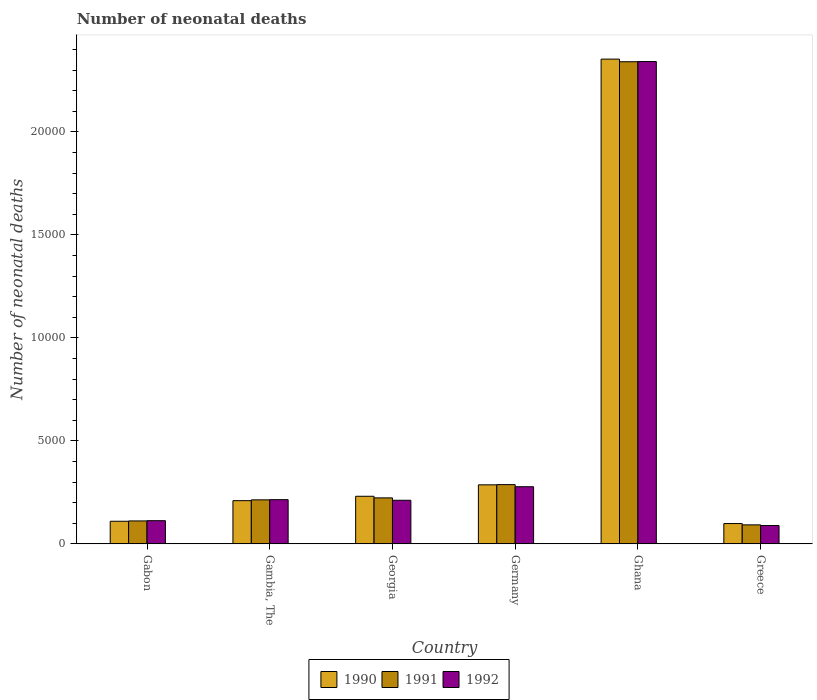How many different coloured bars are there?
Provide a short and direct response. 3. How many bars are there on the 1st tick from the left?
Give a very brief answer. 3. What is the label of the 1st group of bars from the left?
Your answer should be very brief. Gabon. What is the number of neonatal deaths in in 1990 in Georgia?
Offer a very short reply. 2310. Across all countries, what is the maximum number of neonatal deaths in in 1990?
Make the answer very short. 2.35e+04. Across all countries, what is the minimum number of neonatal deaths in in 1990?
Offer a terse response. 986. In which country was the number of neonatal deaths in in 1990 maximum?
Provide a succinct answer. Ghana. In which country was the number of neonatal deaths in in 1990 minimum?
Make the answer very short. Greece. What is the total number of neonatal deaths in in 1991 in the graph?
Offer a very short reply. 3.27e+04. What is the difference between the number of neonatal deaths in in 1991 in Gabon and that in Germany?
Provide a succinct answer. -1763. What is the difference between the number of neonatal deaths in in 1990 in Georgia and the number of neonatal deaths in in 1991 in Gambia, The?
Ensure brevity in your answer.  174. What is the average number of neonatal deaths in in 1990 per country?
Ensure brevity in your answer.  5480.67. What is the difference between the number of neonatal deaths in of/in 1990 and number of neonatal deaths in of/in 1992 in Gambia, The?
Give a very brief answer. -48. In how many countries, is the number of neonatal deaths in in 1992 greater than 17000?
Your answer should be very brief. 1. What is the ratio of the number of neonatal deaths in in 1991 in Ghana to that in Greece?
Provide a succinct answer. 25.38. What is the difference between the highest and the second highest number of neonatal deaths in in 1992?
Ensure brevity in your answer.  -2.13e+04. What is the difference between the highest and the lowest number of neonatal deaths in in 1992?
Provide a succinct answer. 2.25e+04. What does the 2nd bar from the left in Georgia represents?
Ensure brevity in your answer.  1991. What is the difference between two consecutive major ticks on the Y-axis?
Make the answer very short. 5000. Does the graph contain any zero values?
Your answer should be compact. No. Does the graph contain grids?
Offer a terse response. No. How are the legend labels stacked?
Your response must be concise. Horizontal. What is the title of the graph?
Give a very brief answer. Number of neonatal deaths. Does "1994" appear as one of the legend labels in the graph?
Provide a short and direct response. No. What is the label or title of the X-axis?
Give a very brief answer. Country. What is the label or title of the Y-axis?
Provide a short and direct response. Number of neonatal deaths. What is the Number of neonatal deaths of 1990 in Gabon?
Provide a succinct answer. 1097. What is the Number of neonatal deaths in 1991 in Gabon?
Your response must be concise. 1113. What is the Number of neonatal deaths of 1992 in Gabon?
Your answer should be compact. 1125. What is the Number of neonatal deaths in 1990 in Gambia, The?
Offer a terse response. 2097. What is the Number of neonatal deaths of 1991 in Gambia, The?
Provide a succinct answer. 2136. What is the Number of neonatal deaths of 1992 in Gambia, The?
Your answer should be very brief. 2145. What is the Number of neonatal deaths of 1990 in Georgia?
Give a very brief answer. 2310. What is the Number of neonatal deaths in 1991 in Georgia?
Your answer should be compact. 2232. What is the Number of neonatal deaths in 1992 in Georgia?
Provide a succinct answer. 2116. What is the Number of neonatal deaths in 1990 in Germany?
Provide a succinct answer. 2865. What is the Number of neonatal deaths in 1991 in Germany?
Your response must be concise. 2876. What is the Number of neonatal deaths in 1992 in Germany?
Offer a terse response. 2773. What is the Number of neonatal deaths of 1990 in Ghana?
Ensure brevity in your answer.  2.35e+04. What is the Number of neonatal deaths of 1991 in Ghana?
Your answer should be very brief. 2.34e+04. What is the Number of neonatal deaths in 1992 in Ghana?
Give a very brief answer. 2.34e+04. What is the Number of neonatal deaths in 1990 in Greece?
Offer a very short reply. 986. What is the Number of neonatal deaths in 1991 in Greece?
Offer a terse response. 922. What is the Number of neonatal deaths in 1992 in Greece?
Make the answer very short. 889. Across all countries, what is the maximum Number of neonatal deaths of 1990?
Your response must be concise. 2.35e+04. Across all countries, what is the maximum Number of neonatal deaths in 1991?
Your answer should be very brief. 2.34e+04. Across all countries, what is the maximum Number of neonatal deaths of 1992?
Your answer should be compact. 2.34e+04. Across all countries, what is the minimum Number of neonatal deaths in 1990?
Provide a short and direct response. 986. Across all countries, what is the minimum Number of neonatal deaths in 1991?
Your answer should be very brief. 922. Across all countries, what is the minimum Number of neonatal deaths in 1992?
Your answer should be very brief. 889. What is the total Number of neonatal deaths of 1990 in the graph?
Offer a terse response. 3.29e+04. What is the total Number of neonatal deaths of 1991 in the graph?
Offer a very short reply. 3.27e+04. What is the total Number of neonatal deaths of 1992 in the graph?
Give a very brief answer. 3.25e+04. What is the difference between the Number of neonatal deaths of 1990 in Gabon and that in Gambia, The?
Provide a succinct answer. -1000. What is the difference between the Number of neonatal deaths in 1991 in Gabon and that in Gambia, The?
Give a very brief answer. -1023. What is the difference between the Number of neonatal deaths of 1992 in Gabon and that in Gambia, The?
Provide a succinct answer. -1020. What is the difference between the Number of neonatal deaths of 1990 in Gabon and that in Georgia?
Make the answer very short. -1213. What is the difference between the Number of neonatal deaths in 1991 in Gabon and that in Georgia?
Provide a succinct answer. -1119. What is the difference between the Number of neonatal deaths of 1992 in Gabon and that in Georgia?
Your answer should be very brief. -991. What is the difference between the Number of neonatal deaths in 1990 in Gabon and that in Germany?
Ensure brevity in your answer.  -1768. What is the difference between the Number of neonatal deaths of 1991 in Gabon and that in Germany?
Provide a short and direct response. -1763. What is the difference between the Number of neonatal deaths of 1992 in Gabon and that in Germany?
Give a very brief answer. -1648. What is the difference between the Number of neonatal deaths of 1990 in Gabon and that in Ghana?
Make the answer very short. -2.24e+04. What is the difference between the Number of neonatal deaths in 1991 in Gabon and that in Ghana?
Provide a succinct answer. -2.23e+04. What is the difference between the Number of neonatal deaths in 1992 in Gabon and that in Ghana?
Offer a terse response. -2.23e+04. What is the difference between the Number of neonatal deaths of 1990 in Gabon and that in Greece?
Your answer should be compact. 111. What is the difference between the Number of neonatal deaths in 1991 in Gabon and that in Greece?
Offer a terse response. 191. What is the difference between the Number of neonatal deaths of 1992 in Gabon and that in Greece?
Provide a short and direct response. 236. What is the difference between the Number of neonatal deaths in 1990 in Gambia, The and that in Georgia?
Give a very brief answer. -213. What is the difference between the Number of neonatal deaths in 1991 in Gambia, The and that in Georgia?
Your response must be concise. -96. What is the difference between the Number of neonatal deaths in 1992 in Gambia, The and that in Georgia?
Keep it short and to the point. 29. What is the difference between the Number of neonatal deaths in 1990 in Gambia, The and that in Germany?
Keep it short and to the point. -768. What is the difference between the Number of neonatal deaths in 1991 in Gambia, The and that in Germany?
Offer a very short reply. -740. What is the difference between the Number of neonatal deaths in 1992 in Gambia, The and that in Germany?
Provide a short and direct response. -628. What is the difference between the Number of neonatal deaths in 1990 in Gambia, The and that in Ghana?
Give a very brief answer. -2.14e+04. What is the difference between the Number of neonatal deaths in 1991 in Gambia, The and that in Ghana?
Make the answer very short. -2.13e+04. What is the difference between the Number of neonatal deaths in 1992 in Gambia, The and that in Ghana?
Ensure brevity in your answer.  -2.13e+04. What is the difference between the Number of neonatal deaths of 1990 in Gambia, The and that in Greece?
Your response must be concise. 1111. What is the difference between the Number of neonatal deaths in 1991 in Gambia, The and that in Greece?
Provide a succinct answer. 1214. What is the difference between the Number of neonatal deaths of 1992 in Gambia, The and that in Greece?
Your answer should be compact. 1256. What is the difference between the Number of neonatal deaths in 1990 in Georgia and that in Germany?
Offer a terse response. -555. What is the difference between the Number of neonatal deaths in 1991 in Georgia and that in Germany?
Provide a short and direct response. -644. What is the difference between the Number of neonatal deaths in 1992 in Georgia and that in Germany?
Make the answer very short. -657. What is the difference between the Number of neonatal deaths of 1990 in Georgia and that in Ghana?
Your response must be concise. -2.12e+04. What is the difference between the Number of neonatal deaths of 1991 in Georgia and that in Ghana?
Your answer should be very brief. -2.12e+04. What is the difference between the Number of neonatal deaths in 1992 in Georgia and that in Ghana?
Offer a terse response. -2.13e+04. What is the difference between the Number of neonatal deaths in 1990 in Georgia and that in Greece?
Make the answer very short. 1324. What is the difference between the Number of neonatal deaths in 1991 in Georgia and that in Greece?
Your response must be concise. 1310. What is the difference between the Number of neonatal deaths of 1992 in Georgia and that in Greece?
Your answer should be compact. 1227. What is the difference between the Number of neonatal deaths in 1990 in Germany and that in Ghana?
Provide a succinct answer. -2.07e+04. What is the difference between the Number of neonatal deaths of 1991 in Germany and that in Ghana?
Your answer should be very brief. -2.05e+04. What is the difference between the Number of neonatal deaths of 1992 in Germany and that in Ghana?
Offer a terse response. -2.06e+04. What is the difference between the Number of neonatal deaths of 1990 in Germany and that in Greece?
Your answer should be compact. 1879. What is the difference between the Number of neonatal deaths of 1991 in Germany and that in Greece?
Ensure brevity in your answer.  1954. What is the difference between the Number of neonatal deaths in 1992 in Germany and that in Greece?
Ensure brevity in your answer.  1884. What is the difference between the Number of neonatal deaths in 1990 in Ghana and that in Greece?
Your answer should be compact. 2.25e+04. What is the difference between the Number of neonatal deaths of 1991 in Ghana and that in Greece?
Ensure brevity in your answer.  2.25e+04. What is the difference between the Number of neonatal deaths of 1992 in Ghana and that in Greece?
Ensure brevity in your answer.  2.25e+04. What is the difference between the Number of neonatal deaths in 1990 in Gabon and the Number of neonatal deaths in 1991 in Gambia, The?
Provide a short and direct response. -1039. What is the difference between the Number of neonatal deaths of 1990 in Gabon and the Number of neonatal deaths of 1992 in Gambia, The?
Provide a succinct answer. -1048. What is the difference between the Number of neonatal deaths in 1991 in Gabon and the Number of neonatal deaths in 1992 in Gambia, The?
Provide a short and direct response. -1032. What is the difference between the Number of neonatal deaths of 1990 in Gabon and the Number of neonatal deaths of 1991 in Georgia?
Make the answer very short. -1135. What is the difference between the Number of neonatal deaths of 1990 in Gabon and the Number of neonatal deaths of 1992 in Georgia?
Keep it short and to the point. -1019. What is the difference between the Number of neonatal deaths in 1991 in Gabon and the Number of neonatal deaths in 1992 in Georgia?
Ensure brevity in your answer.  -1003. What is the difference between the Number of neonatal deaths in 1990 in Gabon and the Number of neonatal deaths in 1991 in Germany?
Keep it short and to the point. -1779. What is the difference between the Number of neonatal deaths of 1990 in Gabon and the Number of neonatal deaths of 1992 in Germany?
Your answer should be compact. -1676. What is the difference between the Number of neonatal deaths in 1991 in Gabon and the Number of neonatal deaths in 1992 in Germany?
Your answer should be compact. -1660. What is the difference between the Number of neonatal deaths in 1990 in Gabon and the Number of neonatal deaths in 1991 in Ghana?
Your answer should be very brief. -2.23e+04. What is the difference between the Number of neonatal deaths in 1990 in Gabon and the Number of neonatal deaths in 1992 in Ghana?
Your answer should be very brief. -2.23e+04. What is the difference between the Number of neonatal deaths of 1991 in Gabon and the Number of neonatal deaths of 1992 in Ghana?
Provide a succinct answer. -2.23e+04. What is the difference between the Number of neonatal deaths in 1990 in Gabon and the Number of neonatal deaths in 1991 in Greece?
Provide a short and direct response. 175. What is the difference between the Number of neonatal deaths in 1990 in Gabon and the Number of neonatal deaths in 1992 in Greece?
Your answer should be compact. 208. What is the difference between the Number of neonatal deaths of 1991 in Gabon and the Number of neonatal deaths of 1992 in Greece?
Ensure brevity in your answer.  224. What is the difference between the Number of neonatal deaths of 1990 in Gambia, The and the Number of neonatal deaths of 1991 in Georgia?
Provide a succinct answer. -135. What is the difference between the Number of neonatal deaths in 1991 in Gambia, The and the Number of neonatal deaths in 1992 in Georgia?
Offer a very short reply. 20. What is the difference between the Number of neonatal deaths in 1990 in Gambia, The and the Number of neonatal deaths in 1991 in Germany?
Your answer should be compact. -779. What is the difference between the Number of neonatal deaths of 1990 in Gambia, The and the Number of neonatal deaths of 1992 in Germany?
Your answer should be very brief. -676. What is the difference between the Number of neonatal deaths of 1991 in Gambia, The and the Number of neonatal deaths of 1992 in Germany?
Your answer should be very brief. -637. What is the difference between the Number of neonatal deaths in 1990 in Gambia, The and the Number of neonatal deaths in 1991 in Ghana?
Your answer should be compact. -2.13e+04. What is the difference between the Number of neonatal deaths of 1990 in Gambia, The and the Number of neonatal deaths of 1992 in Ghana?
Provide a short and direct response. -2.13e+04. What is the difference between the Number of neonatal deaths in 1991 in Gambia, The and the Number of neonatal deaths in 1992 in Ghana?
Your response must be concise. -2.13e+04. What is the difference between the Number of neonatal deaths in 1990 in Gambia, The and the Number of neonatal deaths in 1991 in Greece?
Ensure brevity in your answer.  1175. What is the difference between the Number of neonatal deaths in 1990 in Gambia, The and the Number of neonatal deaths in 1992 in Greece?
Your answer should be compact. 1208. What is the difference between the Number of neonatal deaths of 1991 in Gambia, The and the Number of neonatal deaths of 1992 in Greece?
Provide a succinct answer. 1247. What is the difference between the Number of neonatal deaths in 1990 in Georgia and the Number of neonatal deaths in 1991 in Germany?
Provide a succinct answer. -566. What is the difference between the Number of neonatal deaths of 1990 in Georgia and the Number of neonatal deaths of 1992 in Germany?
Offer a very short reply. -463. What is the difference between the Number of neonatal deaths in 1991 in Georgia and the Number of neonatal deaths in 1992 in Germany?
Provide a short and direct response. -541. What is the difference between the Number of neonatal deaths in 1990 in Georgia and the Number of neonatal deaths in 1991 in Ghana?
Your answer should be very brief. -2.11e+04. What is the difference between the Number of neonatal deaths of 1990 in Georgia and the Number of neonatal deaths of 1992 in Ghana?
Your response must be concise. -2.11e+04. What is the difference between the Number of neonatal deaths in 1991 in Georgia and the Number of neonatal deaths in 1992 in Ghana?
Keep it short and to the point. -2.12e+04. What is the difference between the Number of neonatal deaths of 1990 in Georgia and the Number of neonatal deaths of 1991 in Greece?
Ensure brevity in your answer.  1388. What is the difference between the Number of neonatal deaths of 1990 in Georgia and the Number of neonatal deaths of 1992 in Greece?
Provide a short and direct response. 1421. What is the difference between the Number of neonatal deaths in 1991 in Georgia and the Number of neonatal deaths in 1992 in Greece?
Your response must be concise. 1343. What is the difference between the Number of neonatal deaths of 1990 in Germany and the Number of neonatal deaths of 1991 in Ghana?
Your answer should be very brief. -2.05e+04. What is the difference between the Number of neonatal deaths in 1990 in Germany and the Number of neonatal deaths in 1992 in Ghana?
Give a very brief answer. -2.05e+04. What is the difference between the Number of neonatal deaths of 1991 in Germany and the Number of neonatal deaths of 1992 in Ghana?
Offer a terse response. -2.05e+04. What is the difference between the Number of neonatal deaths in 1990 in Germany and the Number of neonatal deaths in 1991 in Greece?
Keep it short and to the point. 1943. What is the difference between the Number of neonatal deaths of 1990 in Germany and the Number of neonatal deaths of 1992 in Greece?
Provide a succinct answer. 1976. What is the difference between the Number of neonatal deaths of 1991 in Germany and the Number of neonatal deaths of 1992 in Greece?
Your answer should be compact. 1987. What is the difference between the Number of neonatal deaths in 1990 in Ghana and the Number of neonatal deaths in 1991 in Greece?
Your response must be concise. 2.26e+04. What is the difference between the Number of neonatal deaths in 1990 in Ghana and the Number of neonatal deaths in 1992 in Greece?
Offer a terse response. 2.26e+04. What is the difference between the Number of neonatal deaths of 1991 in Ghana and the Number of neonatal deaths of 1992 in Greece?
Your answer should be compact. 2.25e+04. What is the average Number of neonatal deaths of 1990 per country?
Provide a short and direct response. 5480.67. What is the average Number of neonatal deaths of 1991 per country?
Offer a terse response. 5446.67. What is the average Number of neonatal deaths in 1992 per country?
Give a very brief answer. 5409.83. What is the difference between the Number of neonatal deaths of 1990 and Number of neonatal deaths of 1991 in Gambia, The?
Your answer should be compact. -39. What is the difference between the Number of neonatal deaths in 1990 and Number of neonatal deaths in 1992 in Gambia, The?
Make the answer very short. -48. What is the difference between the Number of neonatal deaths in 1990 and Number of neonatal deaths in 1992 in Georgia?
Keep it short and to the point. 194. What is the difference between the Number of neonatal deaths of 1991 and Number of neonatal deaths of 1992 in Georgia?
Make the answer very short. 116. What is the difference between the Number of neonatal deaths of 1990 and Number of neonatal deaths of 1991 in Germany?
Offer a very short reply. -11. What is the difference between the Number of neonatal deaths in 1990 and Number of neonatal deaths in 1992 in Germany?
Provide a succinct answer. 92. What is the difference between the Number of neonatal deaths in 1991 and Number of neonatal deaths in 1992 in Germany?
Offer a very short reply. 103. What is the difference between the Number of neonatal deaths in 1990 and Number of neonatal deaths in 1991 in Ghana?
Provide a short and direct response. 128. What is the difference between the Number of neonatal deaths of 1990 and Number of neonatal deaths of 1992 in Ghana?
Provide a succinct answer. 118. What is the difference between the Number of neonatal deaths in 1990 and Number of neonatal deaths in 1991 in Greece?
Your answer should be very brief. 64. What is the difference between the Number of neonatal deaths in 1990 and Number of neonatal deaths in 1992 in Greece?
Ensure brevity in your answer.  97. What is the difference between the Number of neonatal deaths in 1991 and Number of neonatal deaths in 1992 in Greece?
Provide a short and direct response. 33. What is the ratio of the Number of neonatal deaths in 1990 in Gabon to that in Gambia, The?
Your answer should be compact. 0.52. What is the ratio of the Number of neonatal deaths in 1991 in Gabon to that in Gambia, The?
Offer a terse response. 0.52. What is the ratio of the Number of neonatal deaths in 1992 in Gabon to that in Gambia, The?
Ensure brevity in your answer.  0.52. What is the ratio of the Number of neonatal deaths in 1990 in Gabon to that in Georgia?
Make the answer very short. 0.47. What is the ratio of the Number of neonatal deaths in 1991 in Gabon to that in Georgia?
Your answer should be compact. 0.5. What is the ratio of the Number of neonatal deaths of 1992 in Gabon to that in Georgia?
Offer a terse response. 0.53. What is the ratio of the Number of neonatal deaths of 1990 in Gabon to that in Germany?
Ensure brevity in your answer.  0.38. What is the ratio of the Number of neonatal deaths of 1991 in Gabon to that in Germany?
Offer a terse response. 0.39. What is the ratio of the Number of neonatal deaths of 1992 in Gabon to that in Germany?
Give a very brief answer. 0.41. What is the ratio of the Number of neonatal deaths of 1990 in Gabon to that in Ghana?
Offer a very short reply. 0.05. What is the ratio of the Number of neonatal deaths of 1991 in Gabon to that in Ghana?
Keep it short and to the point. 0.05. What is the ratio of the Number of neonatal deaths in 1992 in Gabon to that in Ghana?
Your answer should be compact. 0.05. What is the ratio of the Number of neonatal deaths of 1990 in Gabon to that in Greece?
Keep it short and to the point. 1.11. What is the ratio of the Number of neonatal deaths in 1991 in Gabon to that in Greece?
Keep it short and to the point. 1.21. What is the ratio of the Number of neonatal deaths in 1992 in Gabon to that in Greece?
Keep it short and to the point. 1.27. What is the ratio of the Number of neonatal deaths of 1990 in Gambia, The to that in Georgia?
Give a very brief answer. 0.91. What is the ratio of the Number of neonatal deaths of 1991 in Gambia, The to that in Georgia?
Provide a succinct answer. 0.96. What is the ratio of the Number of neonatal deaths of 1992 in Gambia, The to that in Georgia?
Give a very brief answer. 1.01. What is the ratio of the Number of neonatal deaths of 1990 in Gambia, The to that in Germany?
Your answer should be very brief. 0.73. What is the ratio of the Number of neonatal deaths in 1991 in Gambia, The to that in Germany?
Ensure brevity in your answer.  0.74. What is the ratio of the Number of neonatal deaths in 1992 in Gambia, The to that in Germany?
Your response must be concise. 0.77. What is the ratio of the Number of neonatal deaths in 1990 in Gambia, The to that in Ghana?
Your answer should be very brief. 0.09. What is the ratio of the Number of neonatal deaths in 1991 in Gambia, The to that in Ghana?
Keep it short and to the point. 0.09. What is the ratio of the Number of neonatal deaths in 1992 in Gambia, The to that in Ghana?
Make the answer very short. 0.09. What is the ratio of the Number of neonatal deaths of 1990 in Gambia, The to that in Greece?
Your response must be concise. 2.13. What is the ratio of the Number of neonatal deaths of 1991 in Gambia, The to that in Greece?
Keep it short and to the point. 2.32. What is the ratio of the Number of neonatal deaths in 1992 in Gambia, The to that in Greece?
Provide a short and direct response. 2.41. What is the ratio of the Number of neonatal deaths in 1990 in Georgia to that in Germany?
Offer a very short reply. 0.81. What is the ratio of the Number of neonatal deaths in 1991 in Georgia to that in Germany?
Provide a succinct answer. 0.78. What is the ratio of the Number of neonatal deaths in 1992 in Georgia to that in Germany?
Provide a short and direct response. 0.76. What is the ratio of the Number of neonatal deaths of 1990 in Georgia to that in Ghana?
Provide a short and direct response. 0.1. What is the ratio of the Number of neonatal deaths in 1991 in Georgia to that in Ghana?
Offer a very short reply. 0.1. What is the ratio of the Number of neonatal deaths of 1992 in Georgia to that in Ghana?
Ensure brevity in your answer.  0.09. What is the ratio of the Number of neonatal deaths of 1990 in Georgia to that in Greece?
Give a very brief answer. 2.34. What is the ratio of the Number of neonatal deaths in 1991 in Georgia to that in Greece?
Make the answer very short. 2.42. What is the ratio of the Number of neonatal deaths in 1992 in Georgia to that in Greece?
Offer a very short reply. 2.38. What is the ratio of the Number of neonatal deaths in 1990 in Germany to that in Ghana?
Offer a terse response. 0.12. What is the ratio of the Number of neonatal deaths in 1991 in Germany to that in Ghana?
Ensure brevity in your answer.  0.12. What is the ratio of the Number of neonatal deaths of 1992 in Germany to that in Ghana?
Provide a short and direct response. 0.12. What is the ratio of the Number of neonatal deaths in 1990 in Germany to that in Greece?
Make the answer very short. 2.91. What is the ratio of the Number of neonatal deaths in 1991 in Germany to that in Greece?
Your response must be concise. 3.12. What is the ratio of the Number of neonatal deaths of 1992 in Germany to that in Greece?
Offer a terse response. 3.12. What is the ratio of the Number of neonatal deaths of 1990 in Ghana to that in Greece?
Your answer should be compact. 23.86. What is the ratio of the Number of neonatal deaths in 1991 in Ghana to that in Greece?
Make the answer very short. 25.38. What is the ratio of the Number of neonatal deaths of 1992 in Ghana to that in Greece?
Your response must be concise. 26.33. What is the difference between the highest and the second highest Number of neonatal deaths of 1990?
Provide a succinct answer. 2.07e+04. What is the difference between the highest and the second highest Number of neonatal deaths in 1991?
Provide a succinct answer. 2.05e+04. What is the difference between the highest and the second highest Number of neonatal deaths in 1992?
Provide a succinct answer. 2.06e+04. What is the difference between the highest and the lowest Number of neonatal deaths in 1990?
Your response must be concise. 2.25e+04. What is the difference between the highest and the lowest Number of neonatal deaths of 1991?
Your response must be concise. 2.25e+04. What is the difference between the highest and the lowest Number of neonatal deaths of 1992?
Give a very brief answer. 2.25e+04. 